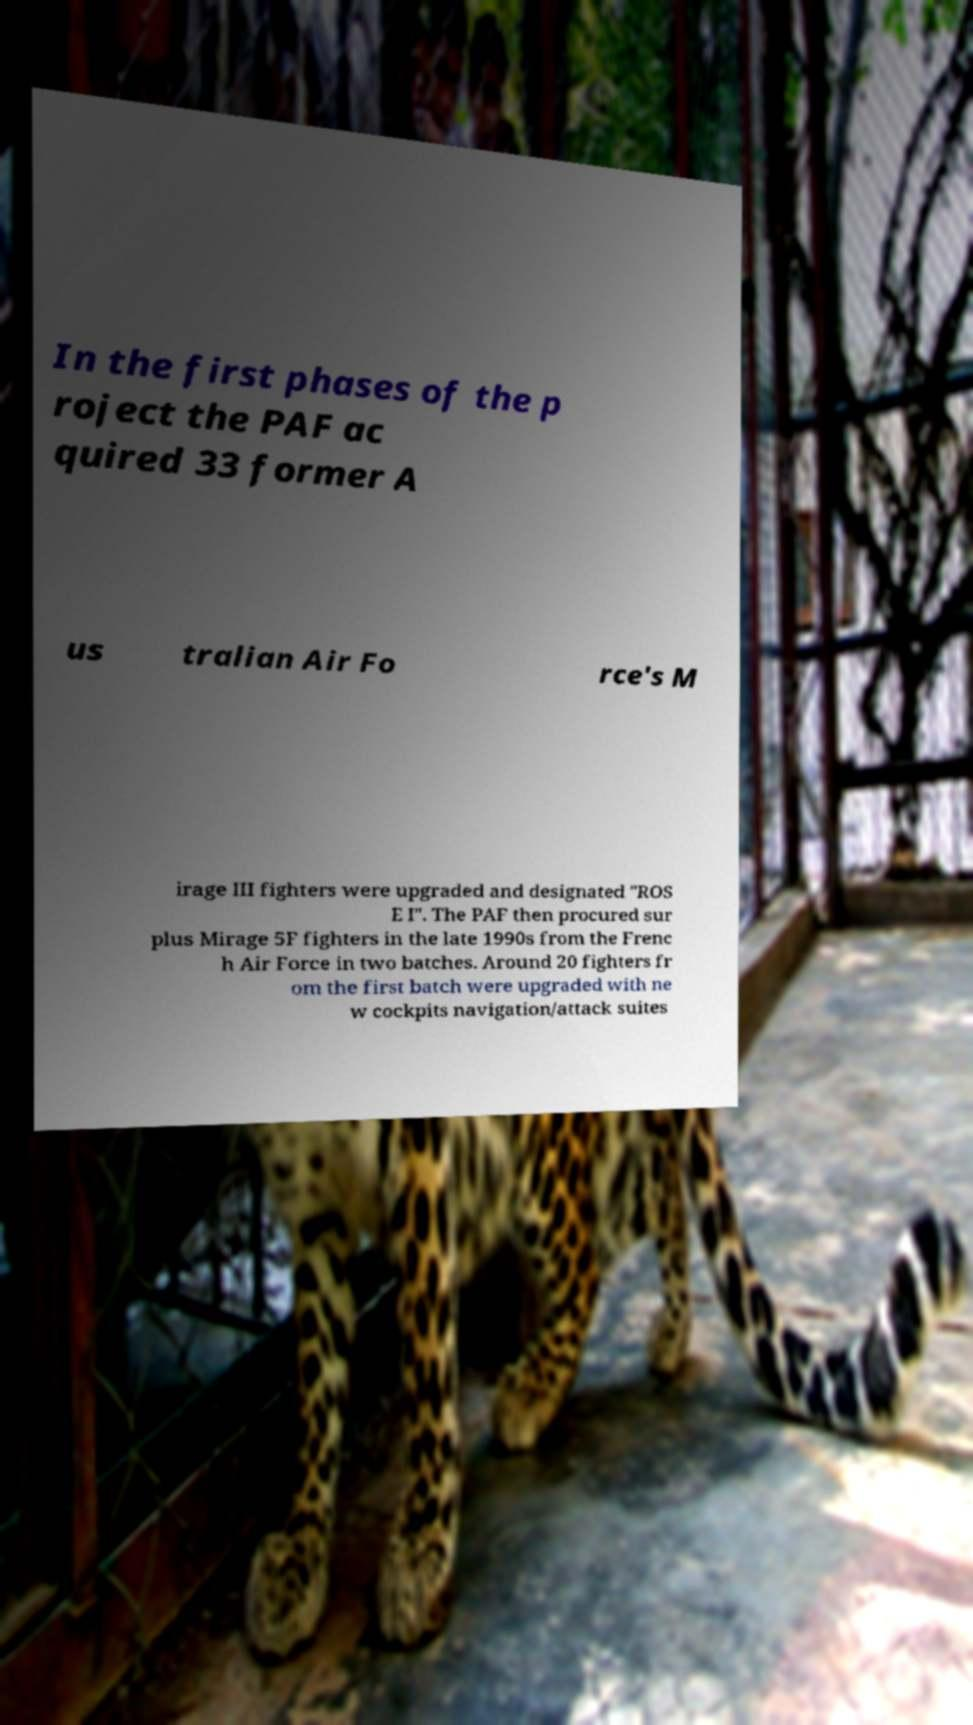What messages or text are displayed in this image? I need them in a readable, typed format. In the first phases of the p roject the PAF ac quired 33 former A us tralian Air Fo rce's M irage III fighters were upgraded and designated "ROS E I". The PAF then procured sur plus Mirage 5F fighters in the late 1990s from the Frenc h Air Force in two batches. Around 20 fighters fr om the first batch were upgraded with ne w cockpits navigation/attack suites 